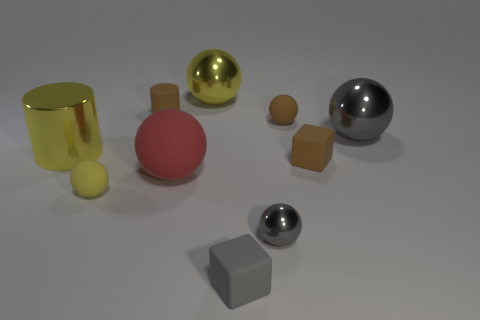There is a gray ball in front of the matte block that is behind the tiny gray matte cube; what number of matte balls are to the right of it? In the image, when considering the position of the gray matte cube which is towards the back, there is one small matte ball situated to its right, aligning with your description of the scene. 